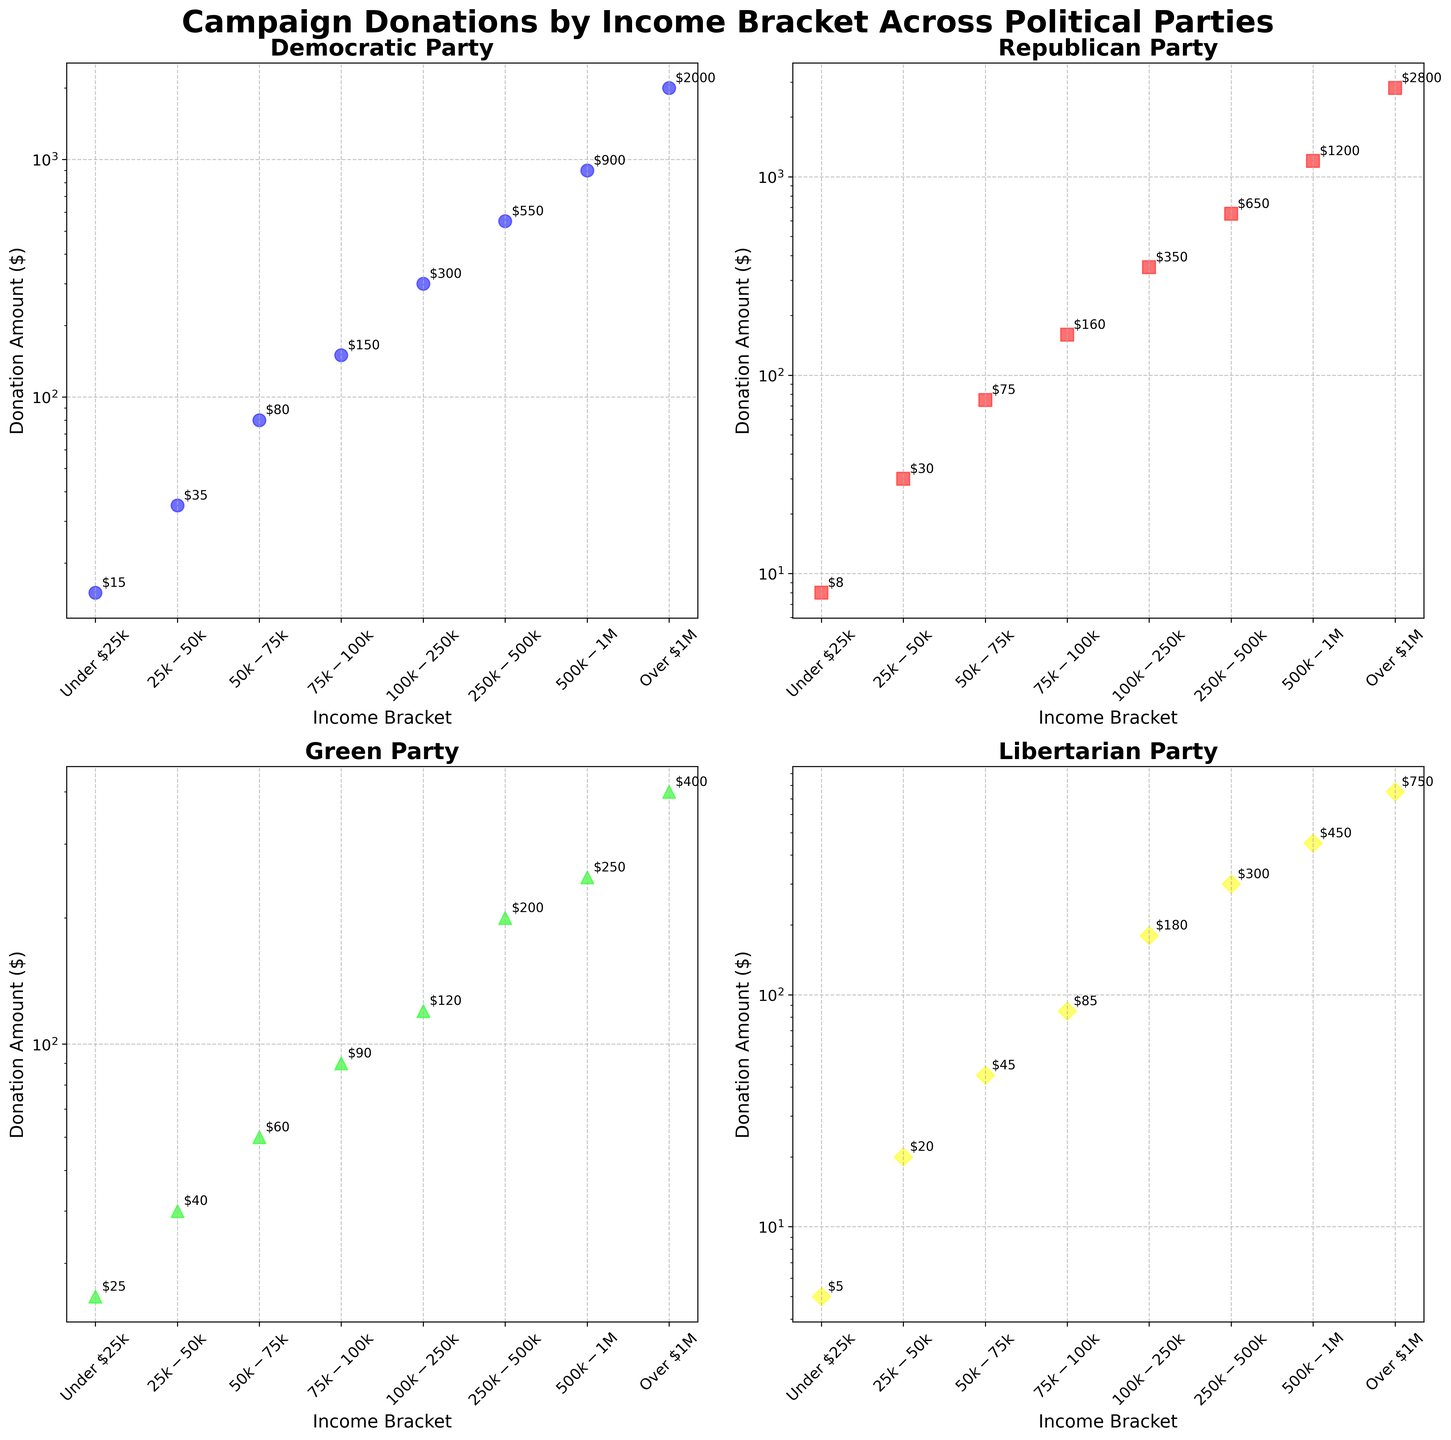what is the title of the figure? The title is available at the top of the figure. Reading it, we find "Campaign Donations by Income Bracket Across Political Parties."
Answer: Campaign Donations by Income Bracket Across Political Parties How many political parties are represented in the figure? There are four subplots, one for each political party, labeled as Democratic Party, Republican Party, Green Party, and Libertarian Party.
Answer: Four Which party received the highest donations from the "$500k-$1M" income bracket? By looking at the scatter plots of each subplot for the $500k-$1M income bracket, we see that the Republican Party received 1200 donations, which is highest among all dataset.
Answer: Republican Party For which income bracket are the donations to the Democratic and Republican parties almost equal? Comparing each income bracket, the donations to Democratic Party (150) and Republican Party (160) are very close in the $75k-$100k category.
Answer: $75k-$100k What's the donation amount for the Green Party from the "Over $1M" income bracket? By examining the subplot dedicated to the Green Party, we see that the "Over $1M" income bracket shows a donation amount of 400.
Answer: 400 Which party has the most skewed distribution towards higher income brackets? Observing all plots, the Republican Party shows a rapidly increasing donation trend for higher income brackets, peaking at 2800 dollars at the "Over $1M" bracket, which is much higher than relatively lower brackets.
Answer: Republican Party What is the median donation amount for the Libertarian Party? The donation amounts for the Libertarian Party are 5, 20, 45, 85, 180, 300, 450, and 750. The median is the middle value, which is (85+180)/2 = 132.5 since there are 8 values.
Answer: 132.5 Which income bracket contributes the most donations to the Libertarian Party? Checking each point on the Libertarian Party plot, we find the "Over $1M" bracket with the highest amount of 750 contributions.
Answer: Over $1M Is there any party with a visible log-scaled axis in the plot? Observations reveal that all subplots show the y-axis with a log scale for donation amounts, representing wide-ranging values efficiently.
Answer: Yes 